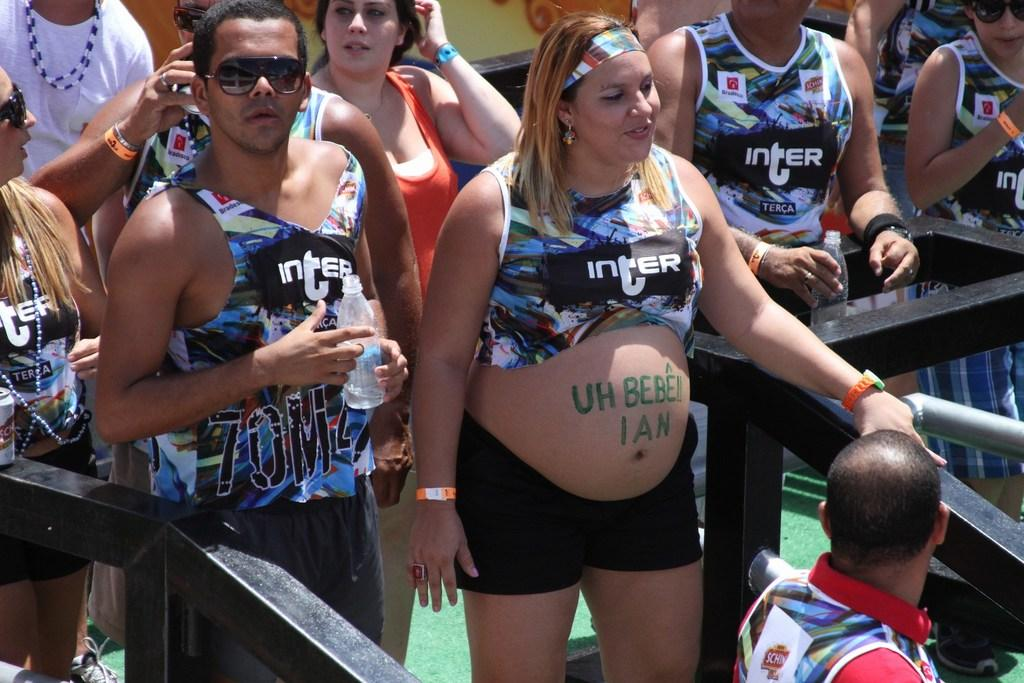<image>
Write a terse but informative summary of the picture. People in the photo are all wearing Inter branded tank tops. 